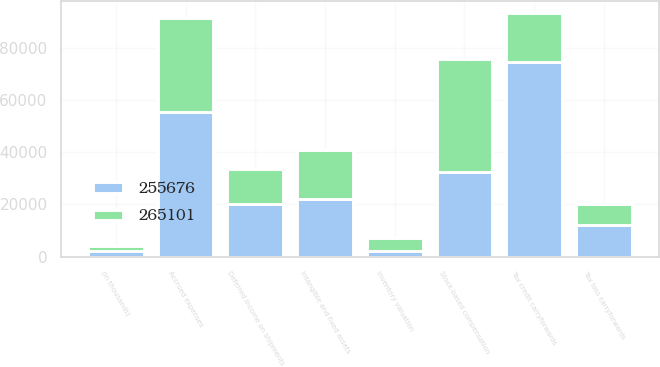<chart> <loc_0><loc_0><loc_500><loc_500><stacked_bar_chart><ecel><fcel>(In thousands)<fcel>Inventory valuation<fcel>Stock-based compensation<fcel>Deferred income on shipments<fcel>Accrued expenses<fcel>Tax loss carryforwards<fcel>Tax credit carryforwards<fcel>Intangible and fixed assets<nl><fcel>255676<fcel>2010<fcel>2050<fcel>32504<fcel>20166<fcel>55513<fcel>11931<fcel>74705<fcel>21939<nl><fcel>265101<fcel>2009<fcel>5116<fcel>43316<fcel>13567<fcel>36016<fcel>8204<fcel>18782<fcel>18782<nl></chart> 